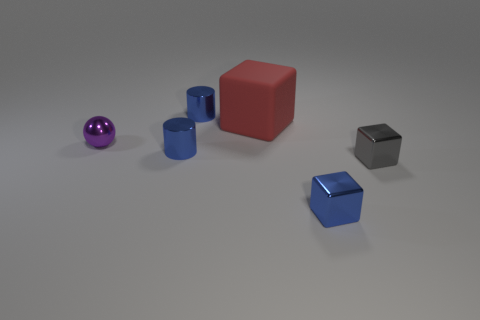Are there any other things that are the same material as the large block?
Offer a very short reply. No. Is there a purple rubber thing?
Ensure brevity in your answer.  No. Do the tiny thing that is in front of the small gray cube and the small ball have the same material?
Keep it short and to the point. Yes. Is there a tiny shiny object of the same shape as the large thing?
Keep it short and to the point. Yes. Is the number of rubber cubes in front of the gray metallic block the same as the number of tiny brown metal cubes?
Offer a very short reply. Yes. What material is the block that is behind the small metallic object right of the tiny blue metal cube?
Provide a succinct answer. Rubber. What is the shape of the small purple metal thing?
Offer a very short reply. Sphere. Are there the same number of big blocks that are on the left side of the tiny shiny ball and red rubber cubes to the right of the large red cube?
Your answer should be compact. Yes. There is a metal cylinder that is behind the metal sphere; does it have the same color as the large matte cube behind the tiny blue cube?
Offer a terse response. No. Is the number of small gray objects right of the tiny gray object greater than the number of metal blocks?
Provide a succinct answer. No. 